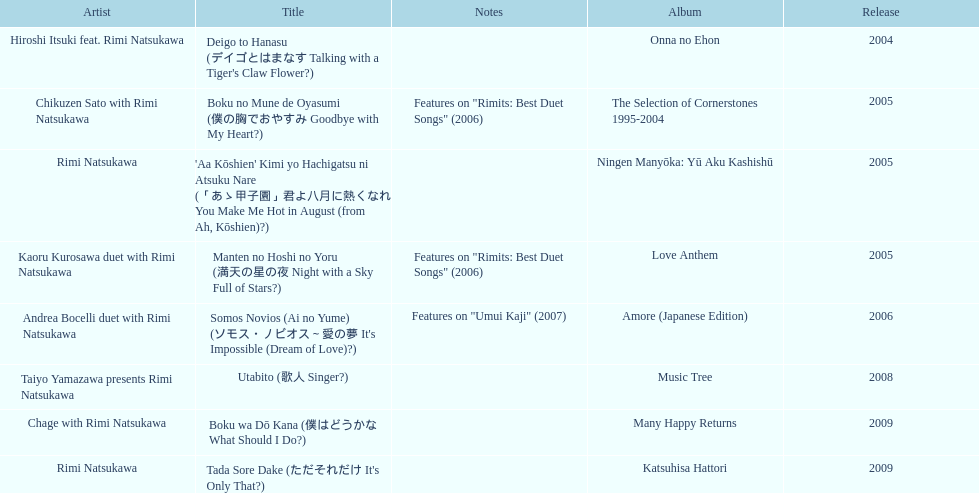What song was this artist on after utabito? Boku wa Dō Kana. 